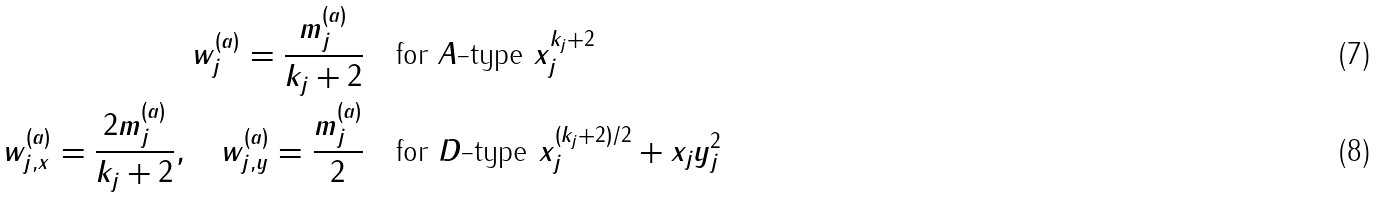<formula> <loc_0><loc_0><loc_500><loc_500>w ^ { ( a ) } _ { j } = \frac { m ^ { ( a ) } _ { j } } { k _ { j } + 2 } \quad & \text {for $A$-type $x_{j}^{k_{j}+2}$} \\ w ^ { ( a ) } _ { j , x } = \frac { 2 m ^ { ( a ) } _ { j } } { k _ { j } + 2 } , \quad w ^ { ( a ) } _ { j , y } = \frac { m ^ { ( a ) } _ { j } } { 2 } \quad & \text {for $D$-type $x_{j}^{(k_{j}+2)/2} + x_{j} y_{j}^{2}$}</formula> 